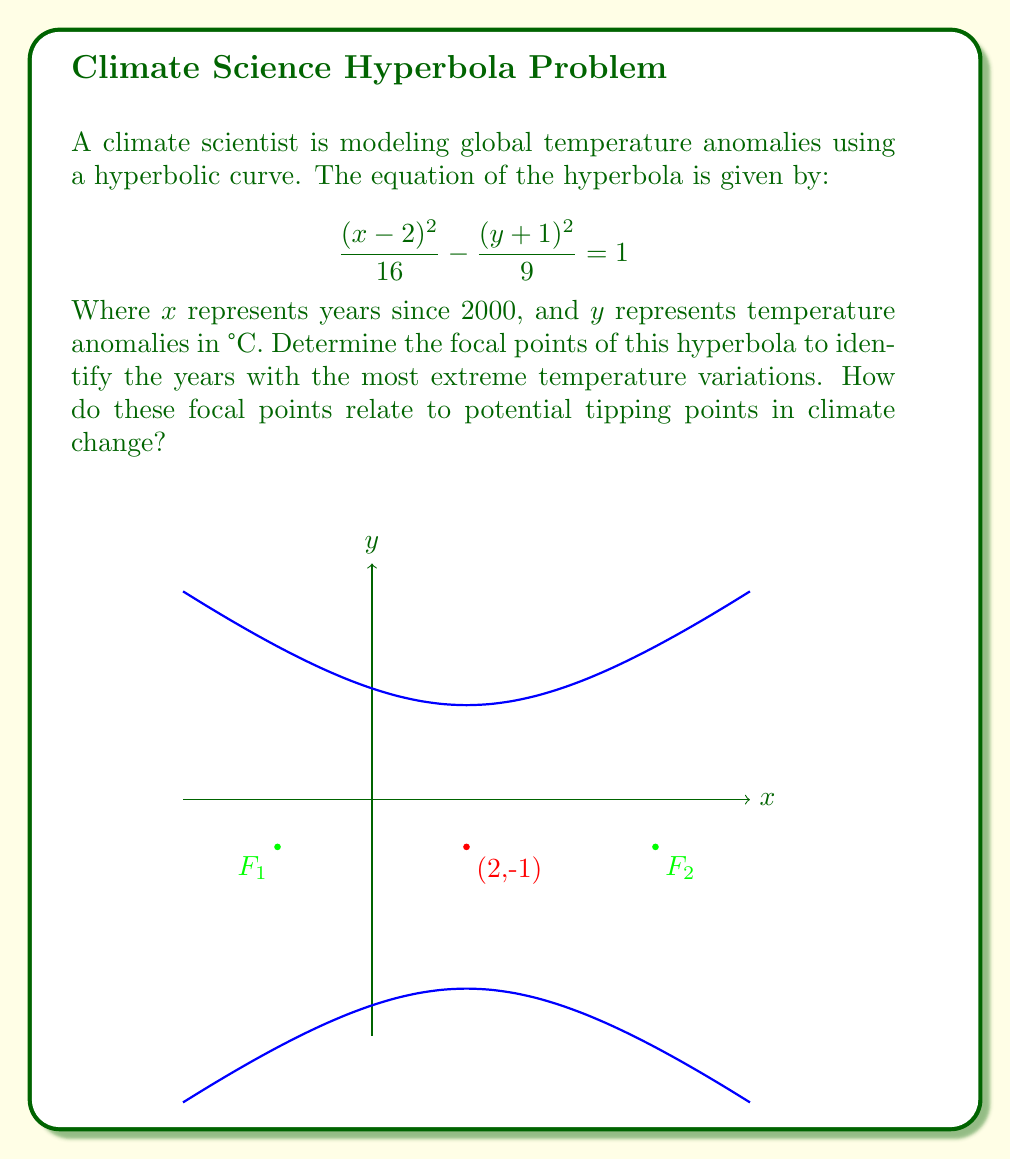Provide a solution to this math problem. To find the focal points of the hyperbola, we'll follow these steps:

1) The standard form of a hyperbola with center (h,k) is:
   $$\frac{(x-h)^2}{a^2} - \frac{(y-k)^2}{b^2} = 1$$

2) Comparing our equation to the standard form, we can identify:
   h = 2, k = -1, a² = 16, b² = 9

3) The focal points of a hyperbola are located on its transverse axis. For a hyperbola with its transverse axis parallel to the x-axis, the focal points are:
   $F_1 = (h-c, k)$ and $F_2 = (h+c, k)$
   where $c^2 = a^2 + b^2$

4) Calculate c:
   $c^2 = a^2 + b^2 = 16 + 9 = 25$
   $c = 5$

5) Therefore, the focal points are:
   $F_1 = (2-5, -1) = (-3, -1)$
   $F_2 = (2+5, -1) = (7, -1)$

6) Interpreting the results:
   The x-coordinates represent years since 2000, so:
   F₁ corresponds to the year 1997 (2000 - 3)
   F₂ corresponds to the year 2007 (2000 + 7)

These focal points indicate years with potentially extreme temperature variations, which could be associated with significant climate events or tipping points. The symmetric nature of the hyperbola suggests that both past (1997) and future (2007) events are equally important in this model, emphasizing the need for long-term climate action and justice.
Answer: Focal points: F₁(-3, -1) and F₂(7, -1), corresponding to years 1997 and 2007. 